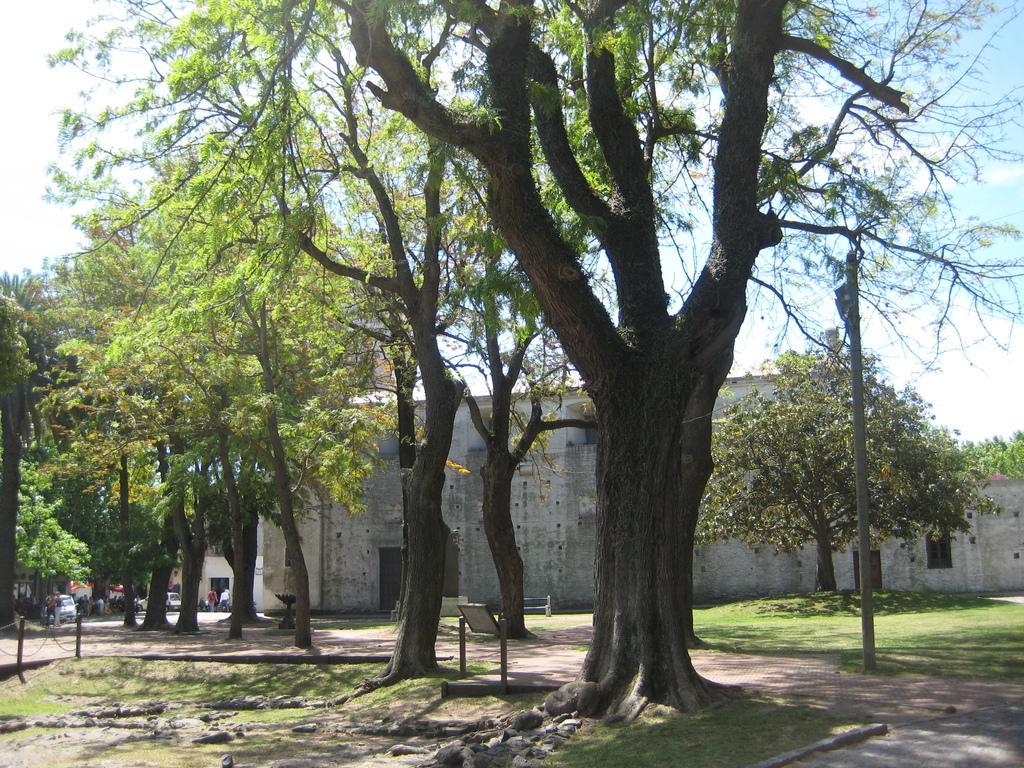Could you give a brief overview of what you see in this image? There are trees and there is a building beside it and there are few vehicles and people in the left corner. 